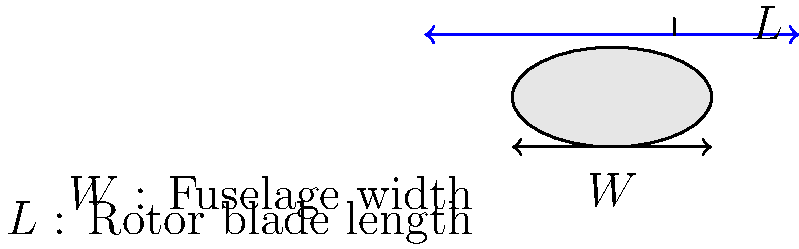A scale model helicopter has a fuselage width ($W$) of 15 cm. The rotor blade length ($L$) is typically 2.5 times the fuselage width for this model. Calculate the rotor blade length in centimeters. To calculate the rotor blade length ($L$) given the fuselage width ($W$), we can follow these steps:

1. Identify the given information:
   - Fuselage width ($W$) = 15 cm
   - Rotor blade length ($L$) is 2.5 times the fuselage width

2. Set up the equation relating rotor blade length to fuselage width:
   $L = 2.5 \times W$

3. Substitute the known value of $W$:
   $L = 2.5 \times 15$ cm

4. Perform the multiplication:
   $L = 37.5$ cm

Therefore, the rotor blade length for this scale model helicopter is 37.5 cm.
Answer: 37.5 cm 